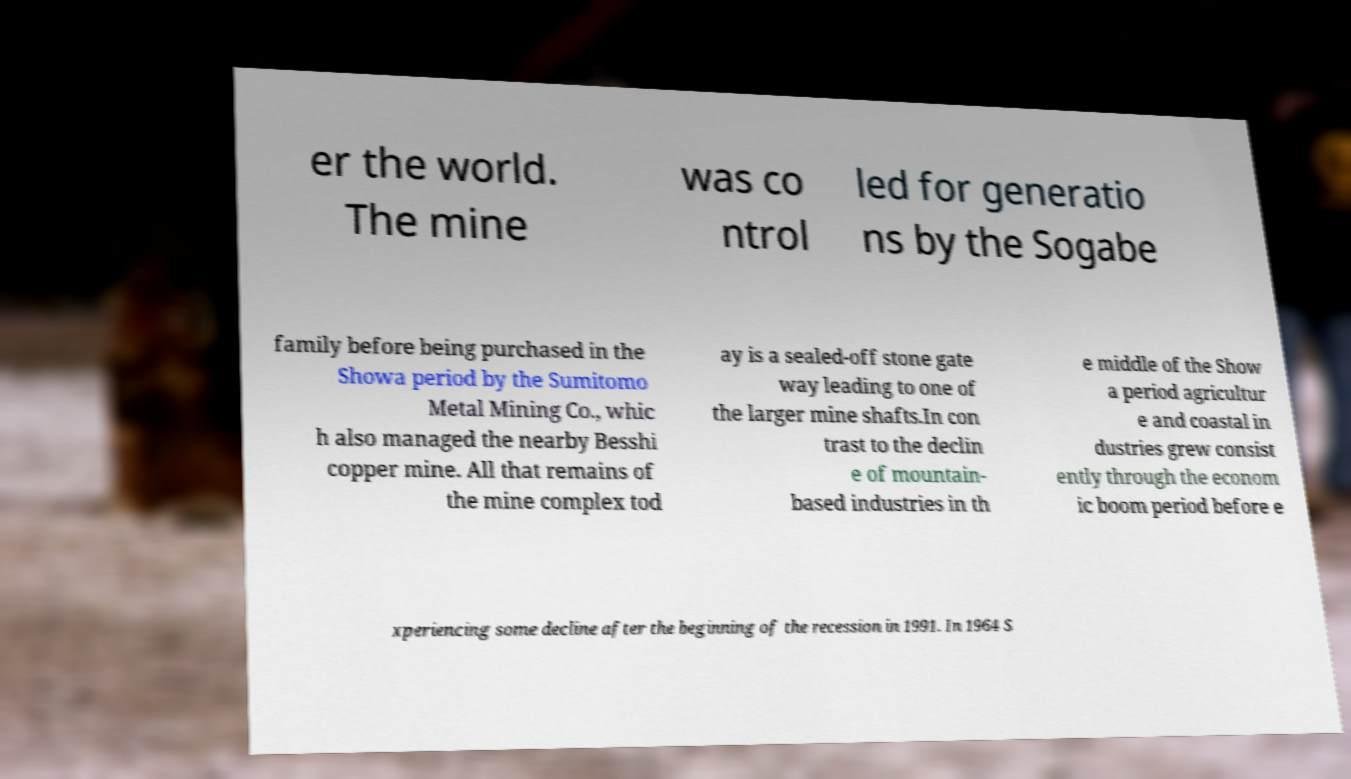Can you read and provide the text displayed in the image?This photo seems to have some interesting text. Can you extract and type it out for me? er the world. The mine was co ntrol led for generatio ns by the Sogabe family before being purchased in the Showa period by the Sumitomo Metal Mining Co., whic h also managed the nearby Besshi copper mine. All that remains of the mine complex tod ay is a sealed-off stone gate way leading to one of the larger mine shafts.In con trast to the declin e of mountain- based industries in th e middle of the Show a period agricultur e and coastal in dustries grew consist ently through the econom ic boom period before e xperiencing some decline after the beginning of the recession in 1991. In 1964 S 